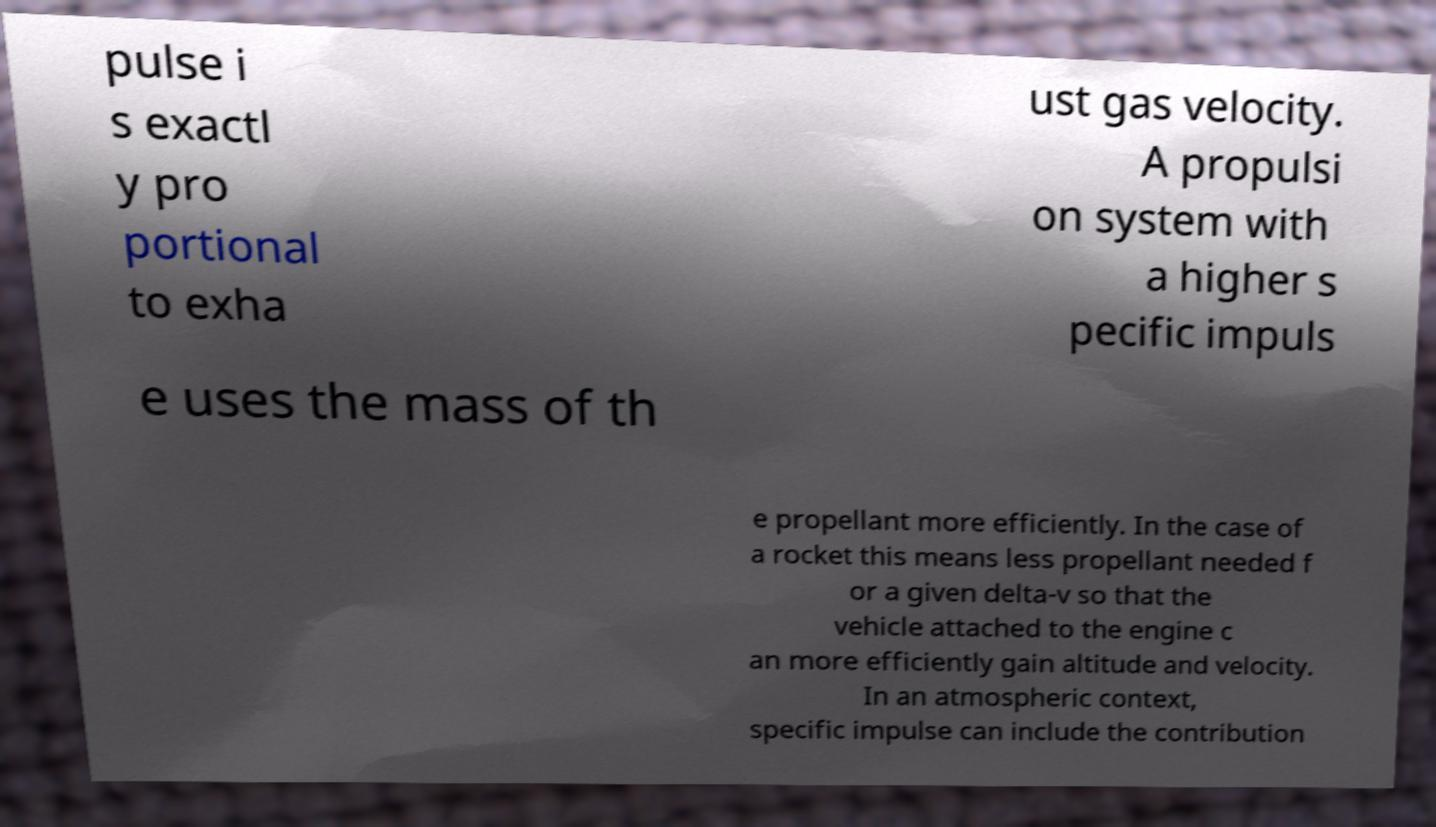What messages or text are displayed in this image? I need them in a readable, typed format. pulse i s exactl y pro portional to exha ust gas velocity. A propulsi on system with a higher s pecific impuls e uses the mass of th e propellant more efficiently. In the case of a rocket this means less propellant needed f or a given delta-v so that the vehicle attached to the engine c an more efficiently gain altitude and velocity. In an atmospheric context, specific impulse can include the contribution 